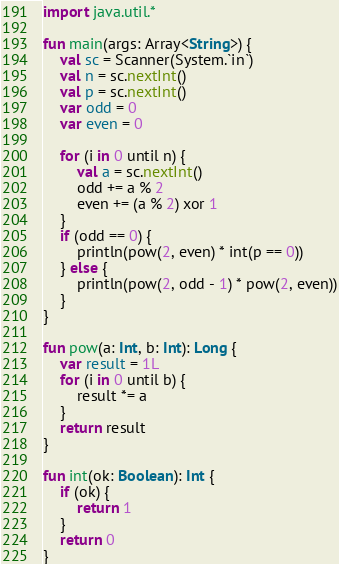<code> <loc_0><loc_0><loc_500><loc_500><_Kotlin_>import java.util.*

fun main(args: Array<String>) {
    val sc = Scanner(System.`in`)
    val n = sc.nextInt()
    val p = sc.nextInt()
    var odd = 0
    var even = 0

    for (i in 0 until n) {
        val a = sc.nextInt()
        odd += a % 2
        even += (a % 2) xor 1
    }
    if (odd == 0) {
        println(pow(2, even) * int(p == 0))
    } else {
        println(pow(2, odd - 1) * pow(2, even))
    }
}

fun pow(a: Int, b: Int): Long {
    var result = 1L
    for (i in 0 until b) {
        result *= a
    }
    return result
}

fun int(ok: Boolean): Int {
    if (ok) {
        return 1
    }
    return 0
}
</code> 